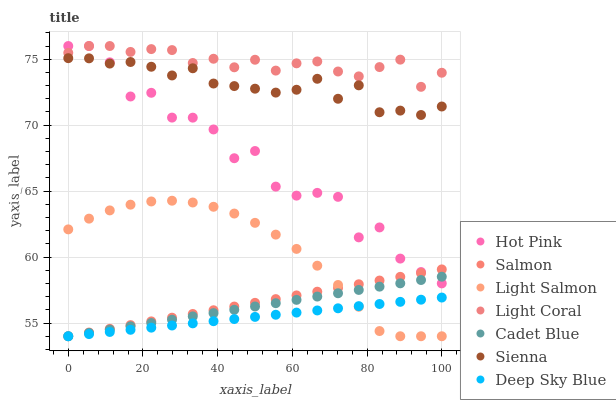Does Deep Sky Blue have the minimum area under the curve?
Answer yes or no. Yes. Does Light Coral have the maximum area under the curve?
Answer yes or no. Yes. Does Light Salmon have the minimum area under the curve?
Answer yes or no. No. Does Light Salmon have the maximum area under the curve?
Answer yes or no. No. Is Cadet Blue the smoothest?
Answer yes or no. Yes. Is Hot Pink the roughest?
Answer yes or no. Yes. Is Light Salmon the smoothest?
Answer yes or no. No. Is Light Salmon the roughest?
Answer yes or no. No. Does Light Salmon have the lowest value?
Answer yes or no. Yes. Does Hot Pink have the lowest value?
Answer yes or no. No. Does Light Coral have the highest value?
Answer yes or no. Yes. Does Light Salmon have the highest value?
Answer yes or no. No. Is Light Salmon less than Sienna?
Answer yes or no. Yes. Is Light Coral greater than Deep Sky Blue?
Answer yes or no. Yes. Does Cadet Blue intersect Salmon?
Answer yes or no. Yes. Is Cadet Blue less than Salmon?
Answer yes or no. No. Is Cadet Blue greater than Salmon?
Answer yes or no. No. Does Light Salmon intersect Sienna?
Answer yes or no. No. 